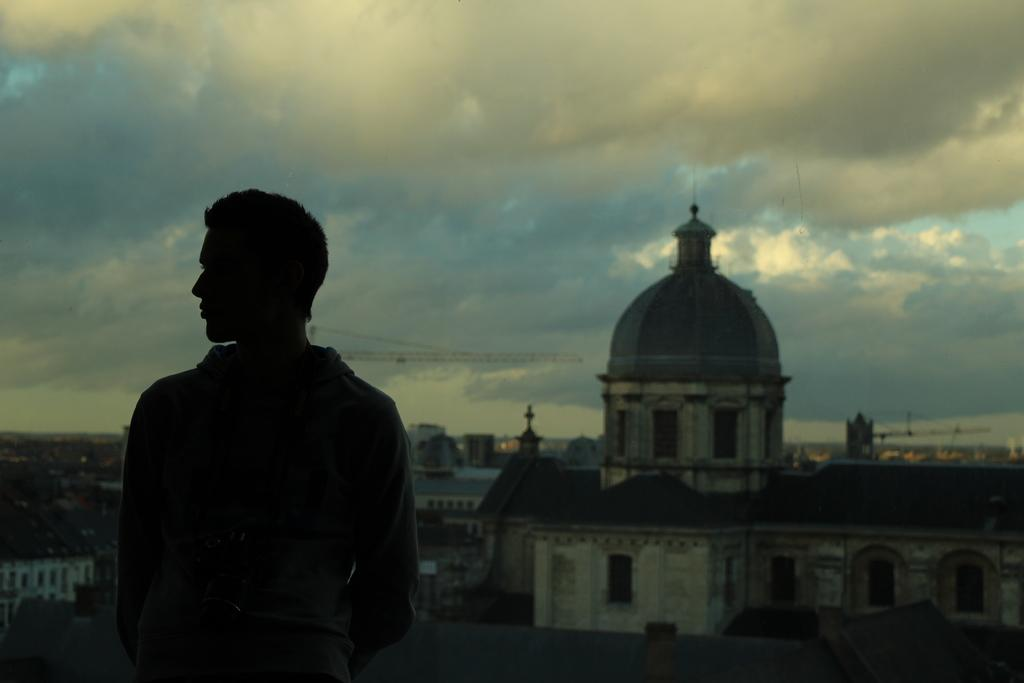What is the main subject in the foreground of the image? There is a person in the foreground of the image. What can be seen in the background of the image? There are buildings and a palace in the background of the image. What is visible at the top of the image? The sky is visible at the top of the image. Can you describe the time of day the image might have been taken? The image may have been taken in the evening, as suggested by the lighting. What type of quince is being used for writing in the image? There is no quince or writing present in the image. How many pans are visible in the image? There are no pans visible in the image. 